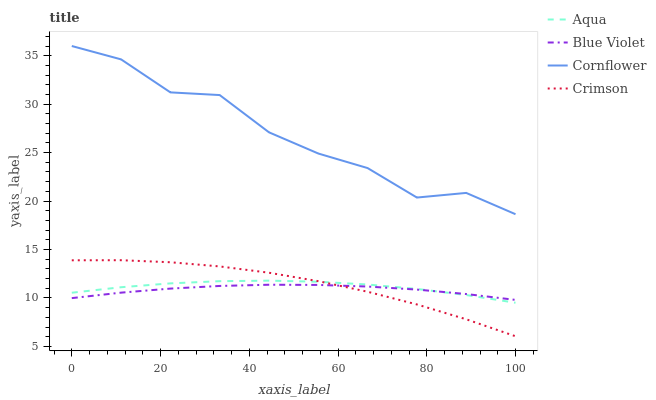Does Blue Violet have the minimum area under the curve?
Answer yes or no. Yes. Does Cornflower have the maximum area under the curve?
Answer yes or no. Yes. Does Aqua have the minimum area under the curve?
Answer yes or no. No. Does Aqua have the maximum area under the curve?
Answer yes or no. No. Is Blue Violet the smoothest?
Answer yes or no. Yes. Is Cornflower the roughest?
Answer yes or no. Yes. Is Aqua the smoothest?
Answer yes or no. No. Is Aqua the roughest?
Answer yes or no. No. Does Aqua have the lowest value?
Answer yes or no. No. Does Cornflower have the highest value?
Answer yes or no. Yes. Does Aqua have the highest value?
Answer yes or no. No. Is Aqua less than Cornflower?
Answer yes or no. Yes. Is Cornflower greater than Blue Violet?
Answer yes or no. Yes. Does Aqua intersect Blue Violet?
Answer yes or no. Yes. Is Aqua less than Blue Violet?
Answer yes or no. No. Is Aqua greater than Blue Violet?
Answer yes or no. No. Does Aqua intersect Cornflower?
Answer yes or no. No. 